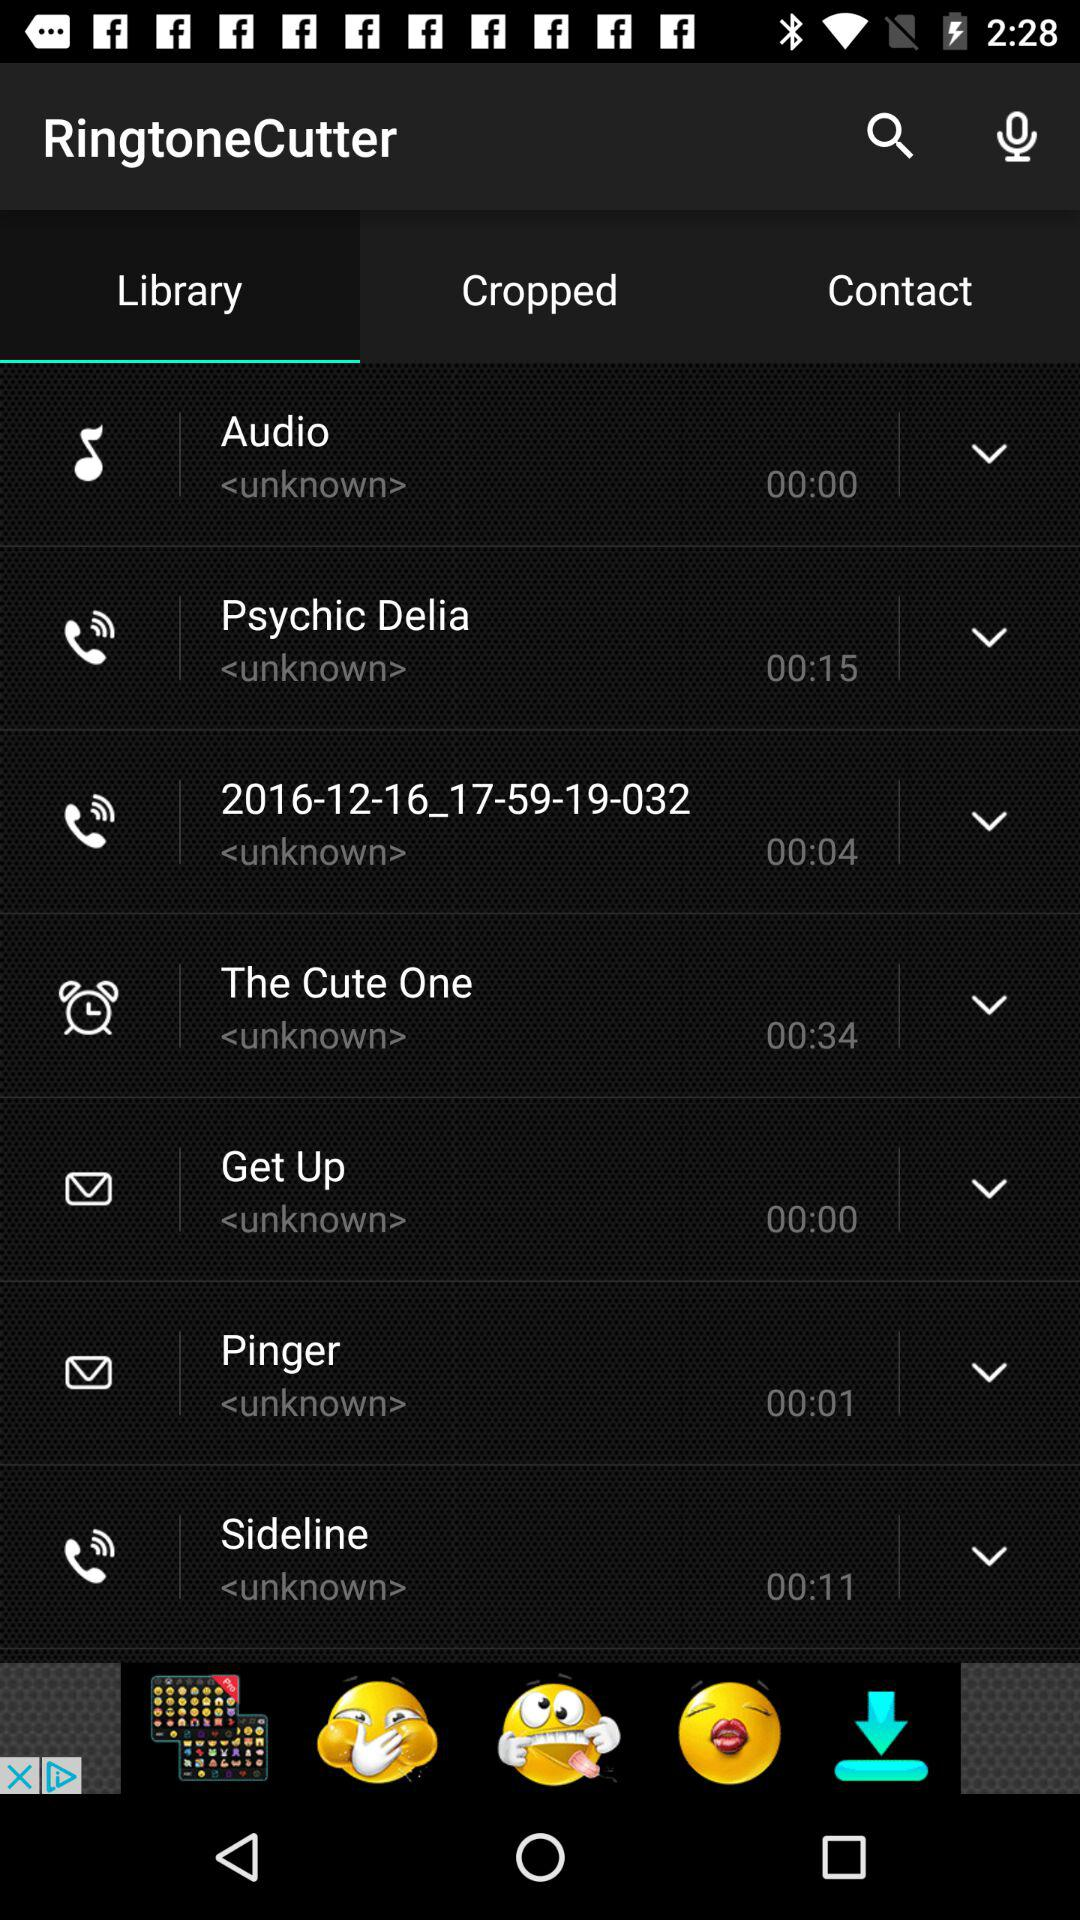What is the duration of the "Psychic Delia" ringtone? The duration of the ringtone is 00:15. 